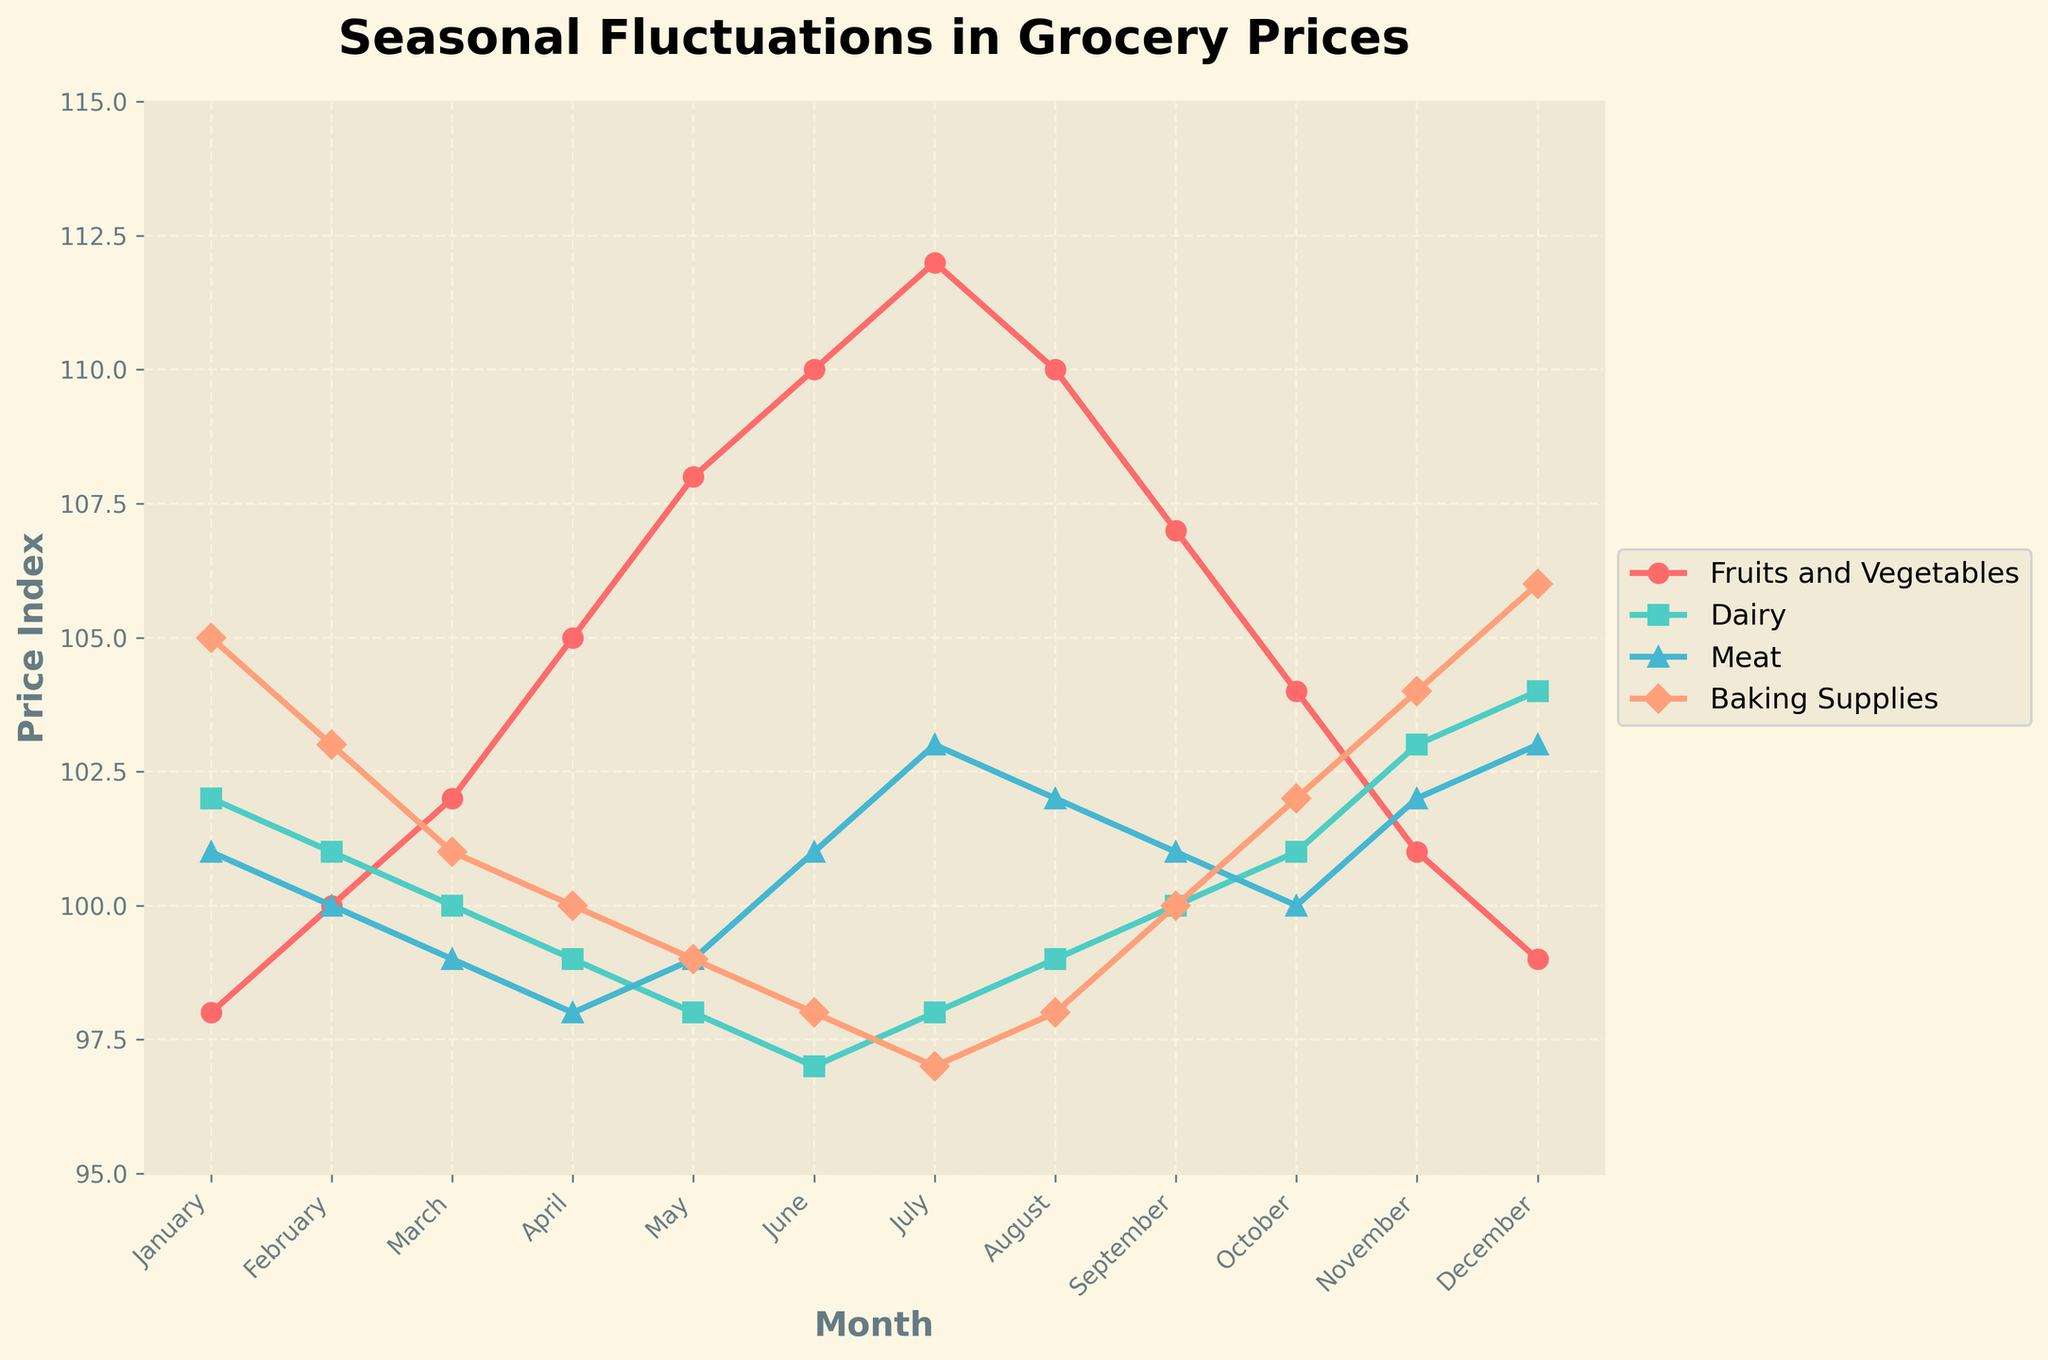Which month has the highest price index for Fruits and Vegetables? Look at the line representing Fruits and Vegetables and find the peak. The highest point happens in July with an index of 112.
Answer: July Between May and December, how much does the price index for Dairy change? Identify Dairy indices for May and December. Dairy in May is 98 and in December is 104. Subtract May's value from December's: 104 - 98 = 6.
Answer: 6 Which category has the most consistent price throughout the year? Visually inspect which line has the least fluctuation. Dairy appears the flattest, indicating the most consistency in prices.
Answer: Dairy In which month is the Meat price index equal to 99? Locate where the Meat line hits 99 on the y-axis, which happens in March and May.
Answer: March and May What is the average price index for Baking Supplies over the entire year? Sum all Baking Supplies monthly indices and divide by 12: (105 + 103 + 101 + 100 + 99 + 98 + 97 + 98 + 100 + 102 + 104 + 106)/12 = 100.25.
Answer: 100.25 Compare the price indices for Fruits and Vegetables and Meat in August. Which one is higher? Examine August for both categories. Fruits and Vegetables is 110, Meat is 102. Fruits and Vegetables is higher.
Answer: Fruits and Vegetables What is the trend in Dairy prices from March to June? Observe the Dairy line from March (100) to June (97). The price index decreases in this period.
Answer: Decreasing In which two months do Baking Supplies have the same price index? Look for equal values in the Baking Supplies line. February (103) and November (103) share the same index.
Answer: February and November How many months show a Dairy price index above 100? Count the months where Dairy is above 100. This occurs in January, October, November, and December. Four months in total.
Answer: 4 